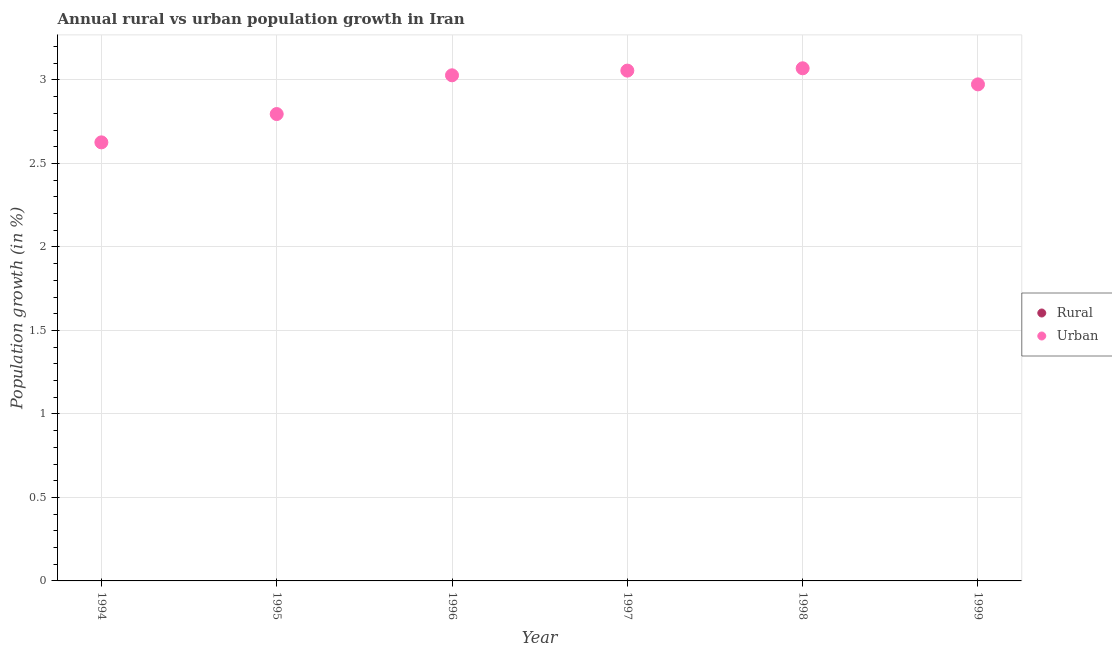Across all years, what is the maximum urban population growth?
Give a very brief answer. 3.07. Across all years, what is the minimum urban population growth?
Offer a very short reply. 2.63. In which year was the urban population growth maximum?
Make the answer very short. 1998. What is the total rural population growth in the graph?
Your answer should be very brief. 0. What is the difference between the urban population growth in 1996 and that in 1998?
Your response must be concise. -0.04. What is the difference between the urban population growth in 1997 and the rural population growth in 1995?
Keep it short and to the point. 3.06. What is the average urban population growth per year?
Your response must be concise. 2.92. What is the ratio of the urban population growth in 1995 to that in 1997?
Ensure brevity in your answer.  0.91. What is the difference between the highest and the second highest urban population growth?
Make the answer very short. 0.01. What is the difference between the highest and the lowest urban population growth?
Provide a succinct answer. 0.44. Is the sum of the urban population growth in 1996 and 1997 greater than the maximum rural population growth across all years?
Offer a very short reply. Yes. Does the rural population growth monotonically increase over the years?
Offer a terse response. No. How many dotlines are there?
Make the answer very short. 1. How many years are there in the graph?
Provide a short and direct response. 6. What is the difference between two consecutive major ticks on the Y-axis?
Provide a succinct answer. 0.5. Are the values on the major ticks of Y-axis written in scientific E-notation?
Offer a terse response. No. Does the graph contain any zero values?
Provide a succinct answer. Yes. Does the graph contain grids?
Offer a terse response. Yes. Where does the legend appear in the graph?
Your answer should be very brief. Center right. How many legend labels are there?
Give a very brief answer. 2. What is the title of the graph?
Offer a terse response. Annual rural vs urban population growth in Iran. Does "Taxes on exports" appear as one of the legend labels in the graph?
Provide a succinct answer. No. What is the label or title of the X-axis?
Ensure brevity in your answer.  Year. What is the label or title of the Y-axis?
Your response must be concise. Population growth (in %). What is the Population growth (in %) in Urban  in 1994?
Make the answer very short. 2.63. What is the Population growth (in %) in Rural in 1995?
Keep it short and to the point. 0. What is the Population growth (in %) of Urban  in 1995?
Give a very brief answer. 2.8. What is the Population growth (in %) of Urban  in 1996?
Your answer should be compact. 3.03. What is the Population growth (in %) of Urban  in 1997?
Provide a succinct answer. 3.06. What is the Population growth (in %) in Urban  in 1998?
Provide a succinct answer. 3.07. What is the Population growth (in %) in Urban  in 1999?
Ensure brevity in your answer.  2.97. Across all years, what is the maximum Population growth (in %) in Urban ?
Provide a succinct answer. 3.07. Across all years, what is the minimum Population growth (in %) of Urban ?
Provide a succinct answer. 2.63. What is the total Population growth (in %) of Urban  in the graph?
Keep it short and to the point. 17.55. What is the difference between the Population growth (in %) of Urban  in 1994 and that in 1995?
Provide a succinct answer. -0.17. What is the difference between the Population growth (in %) in Urban  in 1994 and that in 1996?
Offer a very short reply. -0.4. What is the difference between the Population growth (in %) in Urban  in 1994 and that in 1997?
Your answer should be compact. -0.43. What is the difference between the Population growth (in %) of Urban  in 1994 and that in 1998?
Provide a succinct answer. -0.44. What is the difference between the Population growth (in %) of Urban  in 1994 and that in 1999?
Ensure brevity in your answer.  -0.35. What is the difference between the Population growth (in %) in Urban  in 1995 and that in 1996?
Ensure brevity in your answer.  -0.23. What is the difference between the Population growth (in %) in Urban  in 1995 and that in 1997?
Make the answer very short. -0.26. What is the difference between the Population growth (in %) in Urban  in 1995 and that in 1998?
Give a very brief answer. -0.27. What is the difference between the Population growth (in %) in Urban  in 1995 and that in 1999?
Give a very brief answer. -0.18. What is the difference between the Population growth (in %) of Urban  in 1996 and that in 1997?
Make the answer very short. -0.03. What is the difference between the Population growth (in %) in Urban  in 1996 and that in 1998?
Offer a very short reply. -0.04. What is the difference between the Population growth (in %) in Urban  in 1996 and that in 1999?
Ensure brevity in your answer.  0.05. What is the difference between the Population growth (in %) of Urban  in 1997 and that in 1998?
Make the answer very short. -0.01. What is the difference between the Population growth (in %) in Urban  in 1997 and that in 1999?
Your answer should be very brief. 0.08. What is the difference between the Population growth (in %) of Urban  in 1998 and that in 1999?
Offer a very short reply. 0.1. What is the average Population growth (in %) of Rural per year?
Your answer should be compact. 0. What is the average Population growth (in %) of Urban  per year?
Your answer should be very brief. 2.92. What is the ratio of the Population growth (in %) of Urban  in 1994 to that in 1995?
Your answer should be compact. 0.94. What is the ratio of the Population growth (in %) in Urban  in 1994 to that in 1996?
Provide a short and direct response. 0.87. What is the ratio of the Population growth (in %) of Urban  in 1994 to that in 1997?
Keep it short and to the point. 0.86. What is the ratio of the Population growth (in %) in Urban  in 1994 to that in 1998?
Your answer should be very brief. 0.86. What is the ratio of the Population growth (in %) of Urban  in 1994 to that in 1999?
Ensure brevity in your answer.  0.88. What is the ratio of the Population growth (in %) of Urban  in 1995 to that in 1996?
Provide a succinct answer. 0.92. What is the ratio of the Population growth (in %) of Urban  in 1995 to that in 1997?
Offer a very short reply. 0.91. What is the ratio of the Population growth (in %) of Urban  in 1995 to that in 1998?
Give a very brief answer. 0.91. What is the ratio of the Population growth (in %) of Urban  in 1995 to that in 1999?
Offer a terse response. 0.94. What is the ratio of the Population growth (in %) of Urban  in 1996 to that in 1997?
Ensure brevity in your answer.  0.99. What is the ratio of the Population growth (in %) in Urban  in 1996 to that in 1998?
Your response must be concise. 0.99. What is the ratio of the Population growth (in %) of Urban  in 1996 to that in 1999?
Ensure brevity in your answer.  1.02. What is the ratio of the Population growth (in %) of Urban  in 1997 to that in 1998?
Provide a succinct answer. 1. What is the ratio of the Population growth (in %) of Urban  in 1997 to that in 1999?
Make the answer very short. 1.03. What is the ratio of the Population growth (in %) of Urban  in 1998 to that in 1999?
Your response must be concise. 1.03. What is the difference between the highest and the second highest Population growth (in %) in Urban ?
Provide a succinct answer. 0.01. What is the difference between the highest and the lowest Population growth (in %) in Urban ?
Provide a short and direct response. 0.44. 